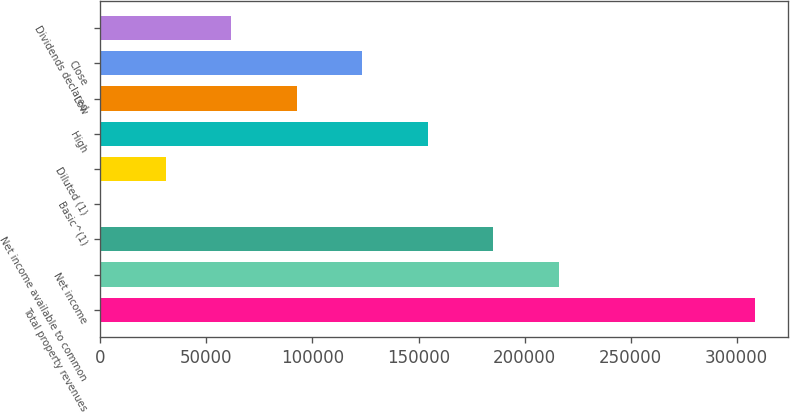Convert chart. <chart><loc_0><loc_0><loc_500><loc_500><bar_chart><fcel>Total property revenues<fcel>Net income<fcel>Net income available to common<fcel>Basic^(1)<fcel>Diluted (1)<fcel>High<fcel>Low<fcel>Close<fcel>Dividends declared<nl><fcel>308646<fcel>216053<fcel>185188<fcel>1.22<fcel>30865.7<fcel>154324<fcel>92594.7<fcel>123459<fcel>61730.2<nl></chart> 